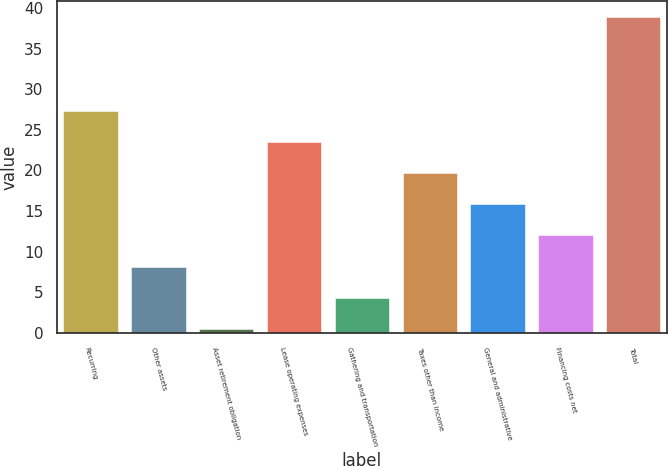Convert chart to OTSL. <chart><loc_0><loc_0><loc_500><loc_500><bar_chart><fcel>Recurring<fcel>Other assets<fcel>Asset retirement obligation<fcel>Lease operating expenses<fcel>Gathering and transportation<fcel>Taxes other than income<fcel>General and administrative<fcel>Financing costs net<fcel>Total<nl><fcel>27.37<fcel>8.17<fcel>0.49<fcel>23.53<fcel>4.33<fcel>19.69<fcel>15.85<fcel>12.01<fcel>38.93<nl></chart> 